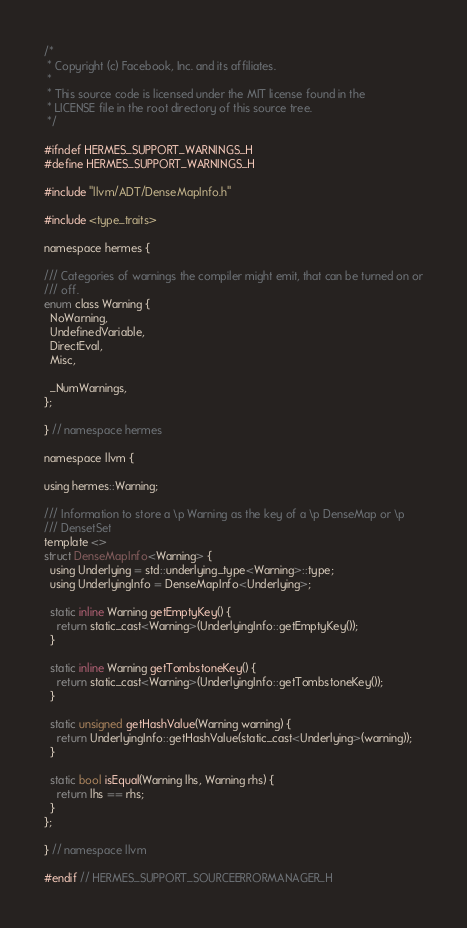<code> <loc_0><loc_0><loc_500><loc_500><_C_>/*
 * Copyright (c) Facebook, Inc. and its affiliates.
 *
 * This source code is licensed under the MIT license found in the
 * LICENSE file in the root directory of this source tree.
 */

#ifndef HERMES_SUPPORT_WARNINGS_H
#define HERMES_SUPPORT_WARNINGS_H

#include "llvm/ADT/DenseMapInfo.h"

#include <type_traits>

namespace hermes {

/// Categories of warnings the compiler might emit, that can be turned on or
/// off.
enum class Warning {
  NoWarning,
  UndefinedVariable,
  DirectEval,
  Misc,

  _NumWarnings,
};

} // namespace hermes

namespace llvm {

using hermes::Warning;

/// Information to store a \p Warning as the key of a \p DenseMap or \p
/// DensetSet
template <>
struct DenseMapInfo<Warning> {
  using Underlying = std::underlying_type<Warning>::type;
  using UnderlyingInfo = DenseMapInfo<Underlying>;

  static inline Warning getEmptyKey() {
    return static_cast<Warning>(UnderlyingInfo::getEmptyKey());
  }

  static inline Warning getTombstoneKey() {
    return static_cast<Warning>(UnderlyingInfo::getTombstoneKey());
  }

  static unsigned getHashValue(Warning warning) {
    return UnderlyingInfo::getHashValue(static_cast<Underlying>(warning));
  }

  static bool isEqual(Warning lhs, Warning rhs) {
    return lhs == rhs;
  }
};

} // namespace llvm

#endif // HERMES_SUPPORT_SOURCEERRORMANAGER_H
</code> 